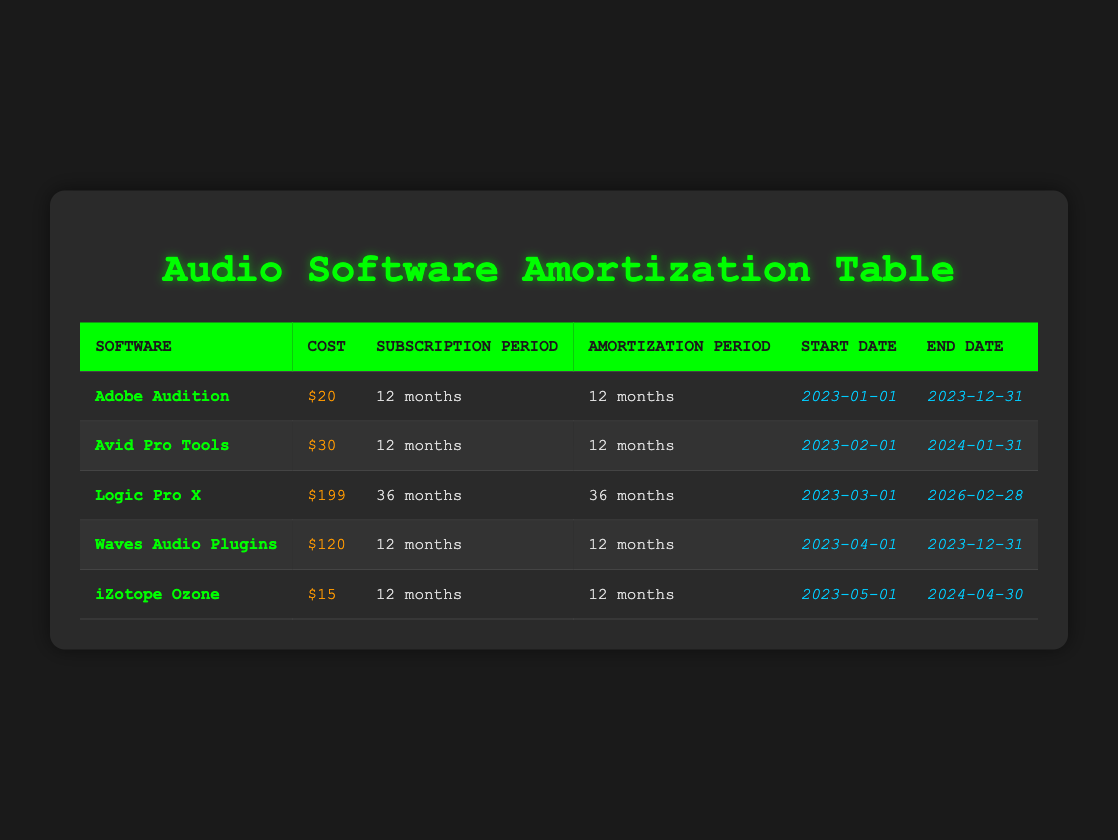What is the cost of Adobe Audition? The table shows the subscription cost for Adobe Audition is listed in the "Cost" column, which states it is $20.
Answer: $20 How long is the subscription period for Avid Pro Tools? Looking in the "Subscription Period" column for Avid Pro Tools, it indicates a duration of 12 months.
Answer: 12 months Which software has the longest amortization period? Comparing the amortization periods listed in the "Amortization Period" column, Logic Pro X has an amortization period of 36 months, which is longer than the others.
Answer: Logic Pro X What is the total subscription cost for all software subscriptions listed? To find the total, sum the costs for all the software: $20 + $30 + $199 + $120 + $15 = $384.
Answer: $384 Is iZotope Ozone subscribed for longer than 12 months? Inspecting the "Subscription Period" column for iZotope Ozone shows it is for 12 months, confirming it is not longer.
Answer: No How many software subscriptions have a cost greater than $100? By examining the "Cost" column and counting, only Logic Pro X ($199) and Waves Audio Plugins ($120) have costs over $100, totaling two software subscriptions.
Answer: 2 What is the difference between the longest and shortest subscription periods? The longest subscription period is for Logic Pro X at 36 months, while the shortest is 12 months for Adobe Audition, Avid Pro Tools, Waves Audio Plugins, and iZotope Ozone. The difference is 36 - 12 = 24 months.
Answer: 24 months What is the average cost of the software subscriptions? To find the average cost, first calculate the total cost ($384) and divide by the number of software subscriptions (5): 384 / 5 = 76.8.
Answer: $76.8 Does any software have the same subscription period? By inspecting the "Subscription Period" column, both Adobe Audition and Avid Pro Tools have matching subscription periods of 12 months, confirming there are duplicates.
Answer: Yes 